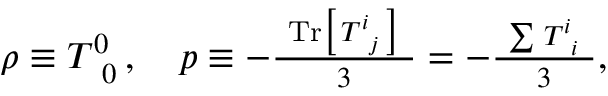<formula> <loc_0><loc_0><loc_500><loc_500>\begin{array} { r } { \rho \equiv T _ { \, 0 } ^ { 0 } \, , \quad p \equiv - \frac { T r \left [ \, T _ { \, j } ^ { i } \, \right ] } { 3 } = - \frac { \sum \, T _ { \, i } ^ { i } } { 3 } , } \end{array}</formula> 